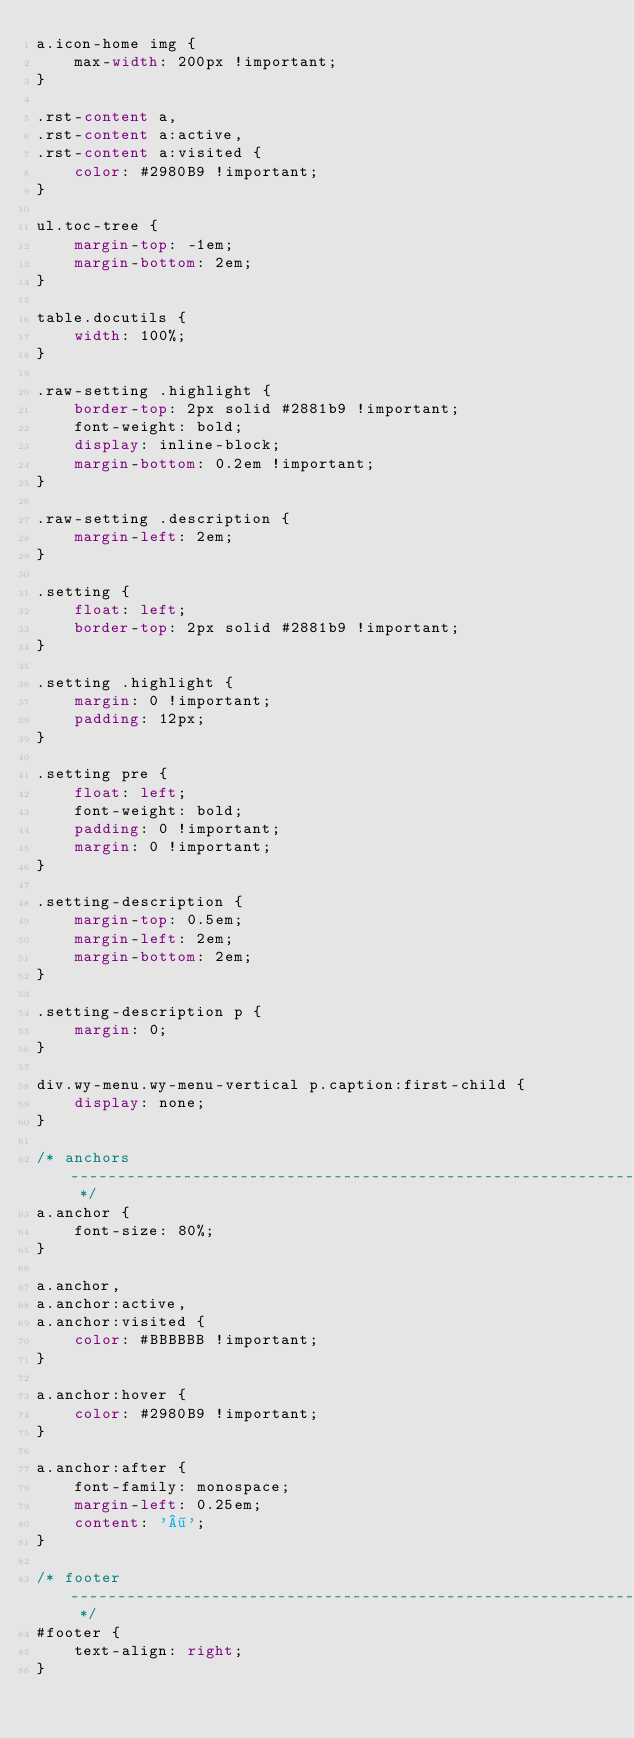Convert code to text. <code><loc_0><loc_0><loc_500><loc_500><_CSS_>a.icon-home img {
    max-width: 200px !important;
}

.rst-content a,
.rst-content a:active,
.rst-content a:visited {
    color: #2980B9 !important;
}

ul.toc-tree {
    margin-top: -1em;
    margin-bottom: 2em;
}

table.docutils {
    width: 100%;
}

.raw-setting .highlight {
    border-top: 2px solid #2881b9 !important;
    font-weight: bold;
    display: inline-block;
    margin-bottom: 0.2em !important;
}

.raw-setting .description {
    margin-left: 2em;
}

.setting {
    float: left;
    border-top: 2px solid #2881b9 !important;
}

.setting .highlight {
    margin: 0 !important;
    padding: 12px;
}

.setting pre {
    float: left;
    font-weight: bold;
    padding: 0 !important;
    margin: 0 !important;
}

.setting-description {
    margin-top: 0.5em;
    margin-left: 2em;
    margin-bottom: 2em;
}

.setting-description p {
    margin: 0;
}

div.wy-menu.wy-menu-vertical p.caption:first-child {
    display: none;
}

/* anchors ----------------------------------------------------------------- */
a.anchor {
    font-size: 80%;
}

a.anchor,
a.anchor:active,
a.anchor:visited {
    color: #BBBBBB !important;
}

a.anchor:hover {
    color: #2980B9 !important;
}

a.anchor:after {
    font-family: monospace;
    margin-left: 0.25em;
    content: '¶';
}

/* footer ------------------------------------------------------------------ */
#footer {
    text-align: right;
}</code> 